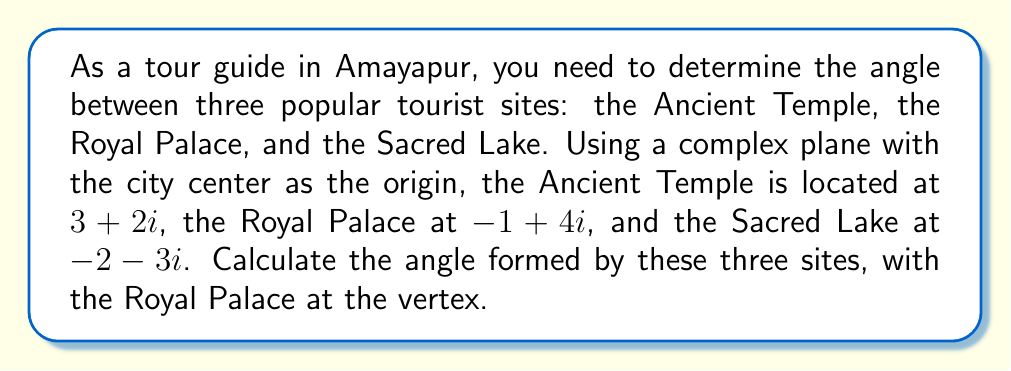What is the answer to this math problem? Let's approach this step-by-step:

1) First, we need to represent the vectors from the Royal Palace to the other two sites:
   
   Vector to Ancient Temple: $v_1 = (3+2i) - (-1+4i) = 4-2i$
   Vector to Sacred Lake: $v_2 = (-2-3i) - (-1+4i) = -1-7i$

2) The angle between these vectors can be found using the argument of their quotient:

   $\theta = \arg(\frac{v_1}{v_2})$

3) Simplify the quotient:
   
   $\frac{v_1}{v_2} = \frac{4-2i}{-1-7i} \cdot \frac{-1+7i}{-1+7i} = \frac{-4+2i-28i-14i^2}{1+49} = \frac{10-30i}{50} = \frac{1-3i}{5}$

4) To find the argument of this complex number, we can use the arctangent function:

   $\theta = \arg(\frac{1-3i}{5}) = \arctan(\frac{-3}{1}) + \pi = -\arctan(3) + \pi$

5) Calculate this value:

   $\theta \approx -1.2490 + 3.1416 \approx 1.8926$ radians

6) Convert to degrees:

   $\theta \approx 1.8926 \cdot \frac{180}{\pi} \approx 108.43°$

[asy]
import geometry;

pair O=(0,0), A=(3,2), B=(-1,4), C=(-2,-3);
draw(O--A,Arrow);
draw(O--B,Arrow);
draw(O--C,Arrow);
draw(B--A,dashed);
draw(B--C,dashed);

label("City Center", O, SW);
label("Ancient Temple", A, NE);
label("Royal Palace", B, NW);
label("Sacred Lake", C, SW);

dot(O);
dot(A);
dot(B);
dot(C);

draw(arc(B,1,0,108.43),Arrow);
label("108.43°", B+(0.7,0.7), NE);
[/asy]
Answer: $108.43°$ 